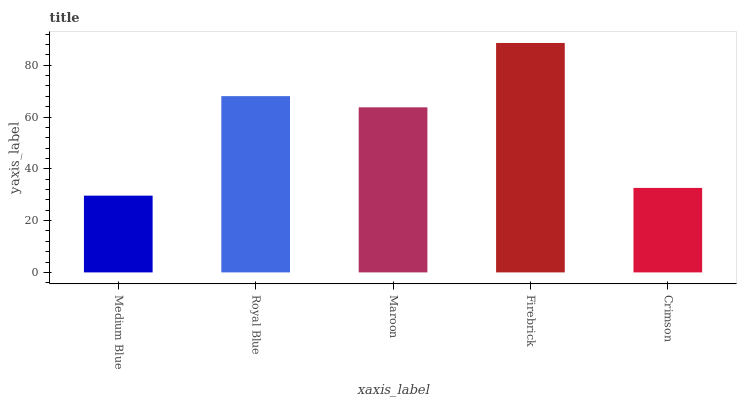Is Medium Blue the minimum?
Answer yes or no. Yes. Is Firebrick the maximum?
Answer yes or no. Yes. Is Royal Blue the minimum?
Answer yes or no. No. Is Royal Blue the maximum?
Answer yes or no. No. Is Royal Blue greater than Medium Blue?
Answer yes or no. Yes. Is Medium Blue less than Royal Blue?
Answer yes or no. Yes. Is Medium Blue greater than Royal Blue?
Answer yes or no. No. Is Royal Blue less than Medium Blue?
Answer yes or no. No. Is Maroon the high median?
Answer yes or no. Yes. Is Maroon the low median?
Answer yes or no. Yes. Is Medium Blue the high median?
Answer yes or no. No. Is Firebrick the low median?
Answer yes or no. No. 